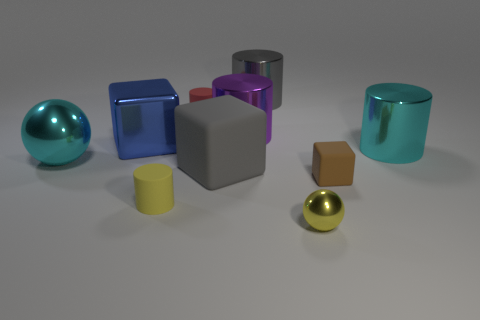Subtract all purple cylinders. How many cylinders are left? 4 Subtract all gray cylinders. How many cylinders are left? 4 Subtract all green cylinders. Subtract all purple blocks. How many cylinders are left? 5 Subtract all balls. How many objects are left? 8 Subtract 1 gray cubes. How many objects are left? 9 Subtract all green things. Subtract all tiny metallic things. How many objects are left? 9 Add 6 big metallic cylinders. How many big metallic cylinders are left? 9 Add 7 small cylinders. How many small cylinders exist? 9 